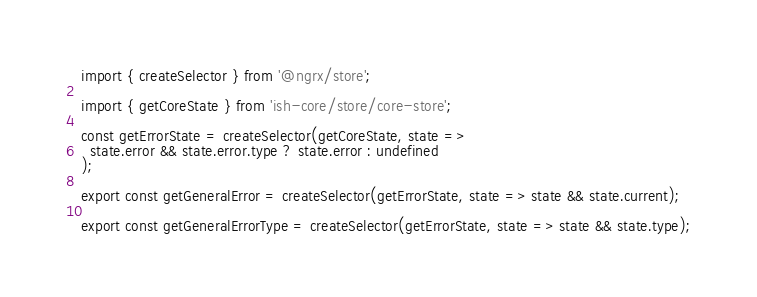<code> <loc_0><loc_0><loc_500><loc_500><_TypeScript_>import { createSelector } from '@ngrx/store';

import { getCoreState } from 'ish-core/store/core-store';

const getErrorState = createSelector(getCoreState, state =>
  state.error && state.error.type ? state.error : undefined
);

export const getGeneralError = createSelector(getErrorState, state => state && state.current);

export const getGeneralErrorType = createSelector(getErrorState, state => state && state.type);
</code> 